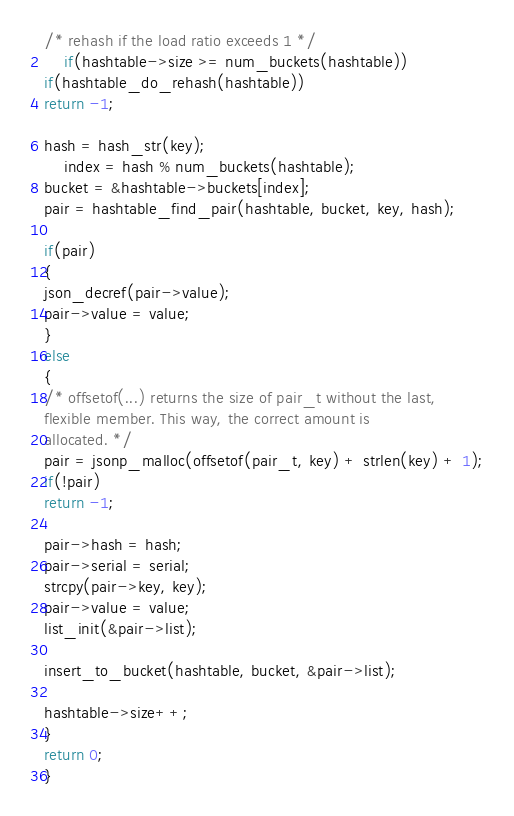Convert code to text. <code><loc_0><loc_0><loc_500><loc_500><_C++_>/* rehash if the load ratio exceeds 1 */
    if(hashtable->size >= num_buckets(hashtable))
if(hashtable_do_rehash(hashtable))
return -1;

hash = hash_str(key);
    index = hash % num_buckets(hashtable);
bucket = &hashtable->buckets[index];
pair = hashtable_find_pair(hashtable, bucket, key, hash);

if(pair)
{
json_decref(pair->value);
pair->value = value;
}
else
{
/* offsetof(...) returns the size of pair_t without the last,
flexible member. This way, the correct amount is
allocated. */
pair = jsonp_malloc(offsetof(pair_t, key) + strlen(key) + 1);
if(!pair)
return -1;

pair->hash = hash;
pair->serial = serial;
strcpy(pair->key, key);
pair->value = value;
list_init(&pair->list);

insert_to_bucket(hashtable, bucket, &pair->list);

hashtable->size++;
}
return 0;
}
</code> 